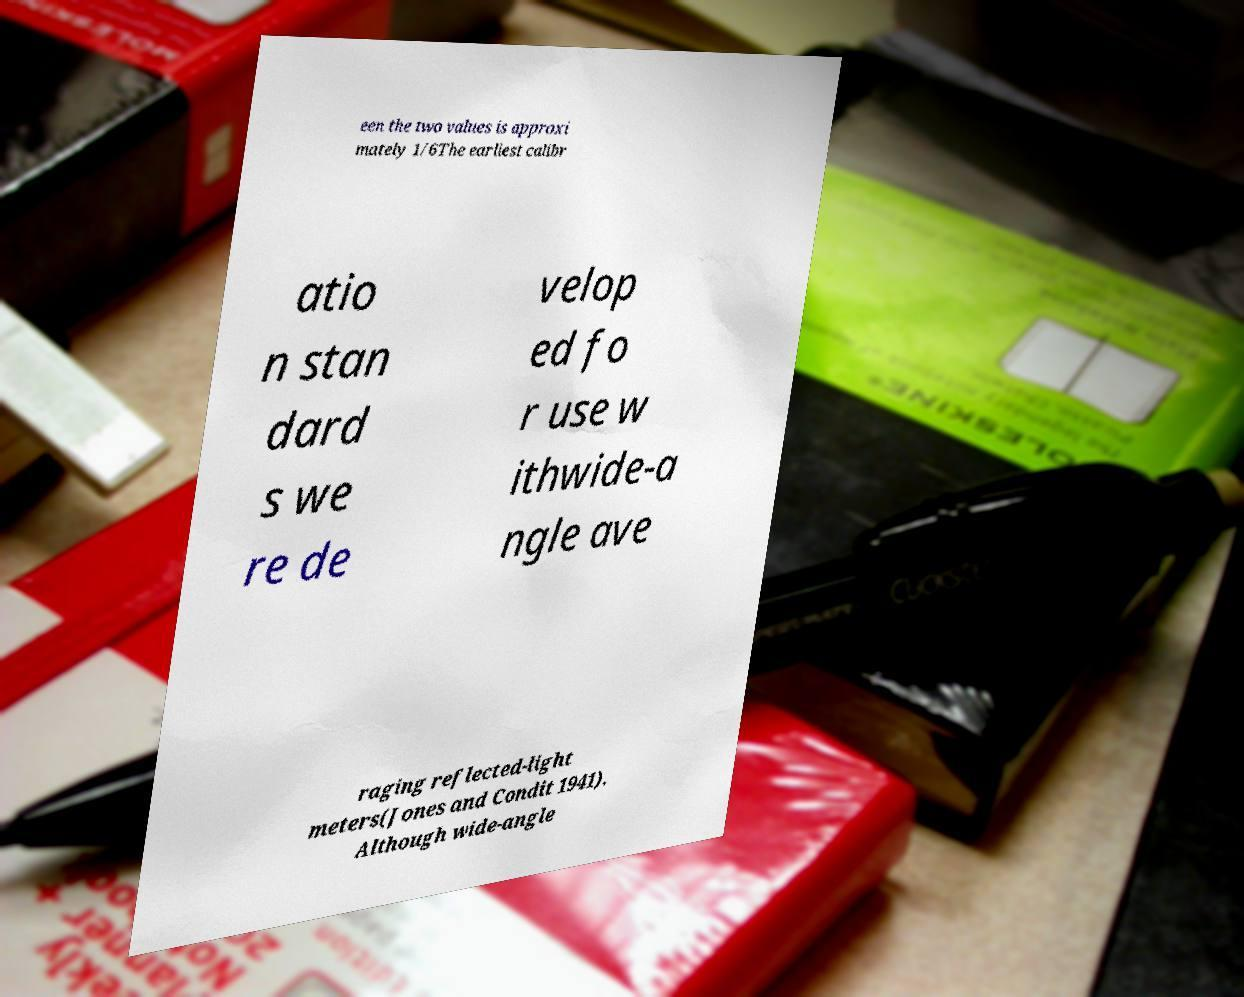What messages or text are displayed in this image? I need them in a readable, typed format. een the two values is approxi mately 1/6The earliest calibr atio n stan dard s we re de velop ed fo r use w ithwide-a ngle ave raging reflected-light meters(Jones and Condit 1941). Although wide-angle 